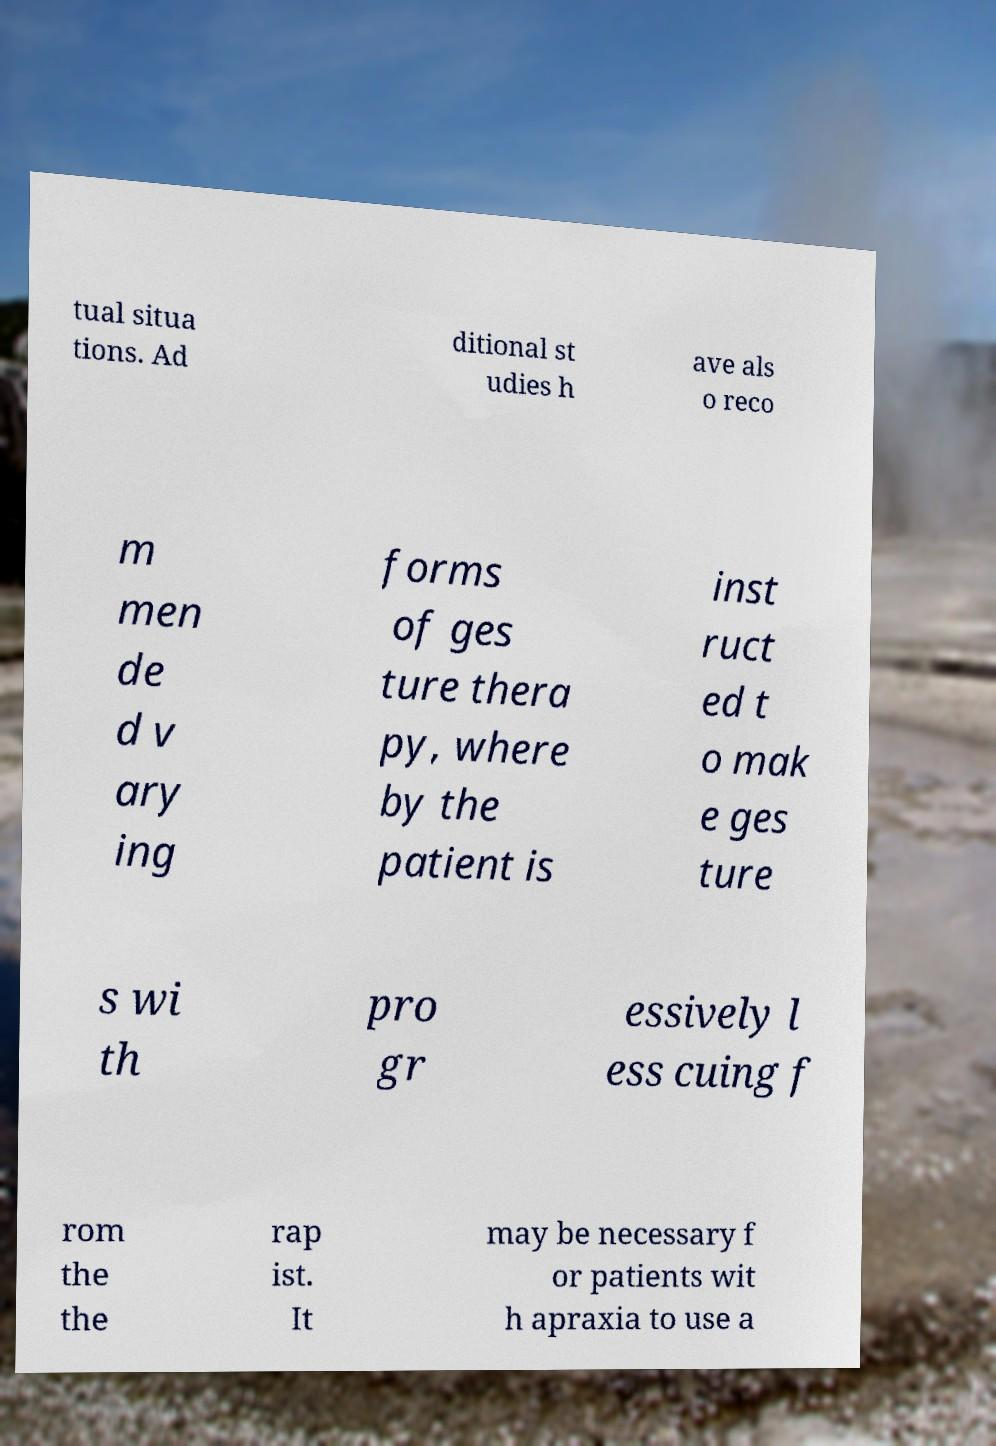Please identify and transcribe the text found in this image. tual situa tions. Ad ditional st udies h ave als o reco m men de d v ary ing forms of ges ture thera py, where by the patient is inst ruct ed t o mak e ges ture s wi th pro gr essively l ess cuing f rom the the rap ist. It may be necessary f or patients wit h apraxia to use a 